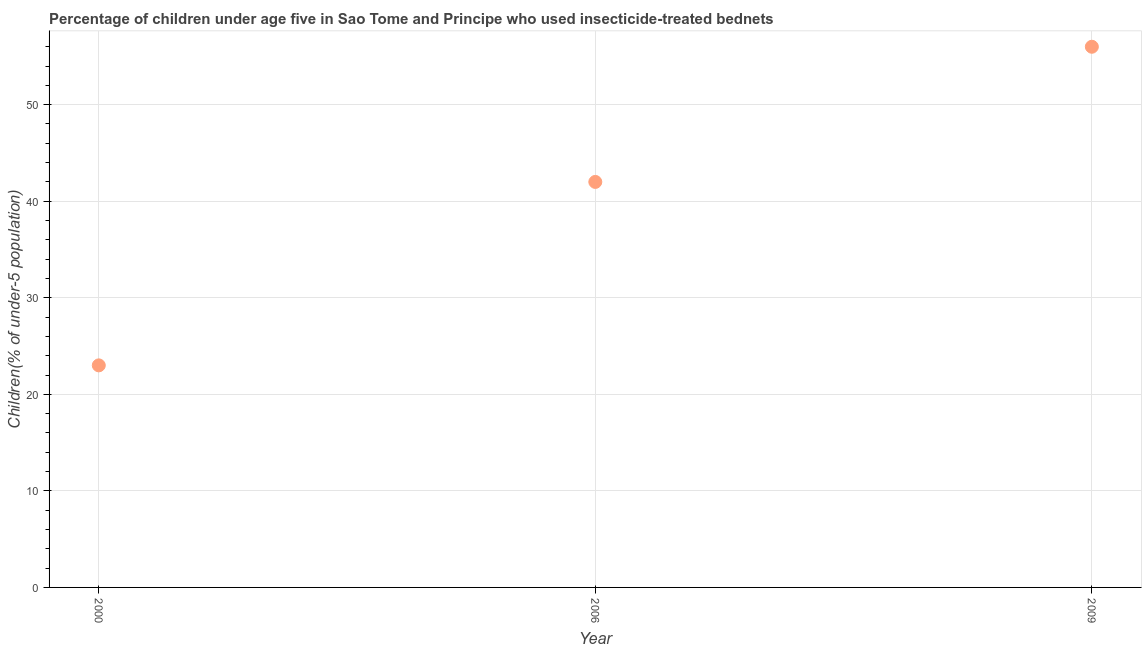What is the percentage of children who use of insecticide-treated bed nets in 2009?
Give a very brief answer. 56. Across all years, what is the maximum percentage of children who use of insecticide-treated bed nets?
Provide a short and direct response. 56. Across all years, what is the minimum percentage of children who use of insecticide-treated bed nets?
Offer a very short reply. 23. In which year was the percentage of children who use of insecticide-treated bed nets maximum?
Provide a succinct answer. 2009. In which year was the percentage of children who use of insecticide-treated bed nets minimum?
Your response must be concise. 2000. What is the sum of the percentage of children who use of insecticide-treated bed nets?
Your response must be concise. 121. What is the difference between the percentage of children who use of insecticide-treated bed nets in 2000 and 2009?
Offer a very short reply. -33. What is the average percentage of children who use of insecticide-treated bed nets per year?
Make the answer very short. 40.33. What is the ratio of the percentage of children who use of insecticide-treated bed nets in 2000 to that in 2006?
Provide a succinct answer. 0.55. Is the percentage of children who use of insecticide-treated bed nets in 2000 less than that in 2009?
Give a very brief answer. Yes. What is the difference between the highest and the second highest percentage of children who use of insecticide-treated bed nets?
Offer a terse response. 14. Is the sum of the percentage of children who use of insecticide-treated bed nets in 2000 and 2006 greater than the maximum percentage of children who use of insecticide-treated bed nets across all years?
Provide a succinct answer. Yes. What is the difference between the highest and the lowest percentage of children who use of insecticide-treated bed nets?
Give a very brief answer. 33. How many dotlines are there?
Make the answer very short. 1. Are the values on the major ticks of Y-axis written in scientific E-notation?
Provide a succinct answer. No. Does the graph contain any zero values?
Offer a terse response. No. Does the graph contain grids?
Your response must be concise. Yes. What is the title of the graph?
Provide a succinct answer. Percentage of children under age five in Sao Tome and Principe who used insecticide-treated bednets. What is the label or title of the X-axis?
Make the answer very short. Year. What is the label or title of the Y-axis?
Your answer should be compact. Children(% of under-5 population). What is the Children(% of under-5 population) in 2000?
Ensure brevity in your answer.  23. What is the difference between the Children(% of under-5 population) in 2000 and 2006?
Offer a terse response. -19. What is the difference between the Children(% of under-5 population) in 2000 and 2009?
Give a very brief answer. -33. What is the ratio of the Children(% of under-5 population) in 2000 to that in 2006?
Ensure brevity in your answer.  0.55. What is the ratio of the Children(% of under-5 population) in 2000 to that in 2009?
Ensure brevity in your answer.  0.41. What is the ratio of the Children(% of under-5 population) in 2006 to that in 2009?
Keep it short and to the point. 0.75. 